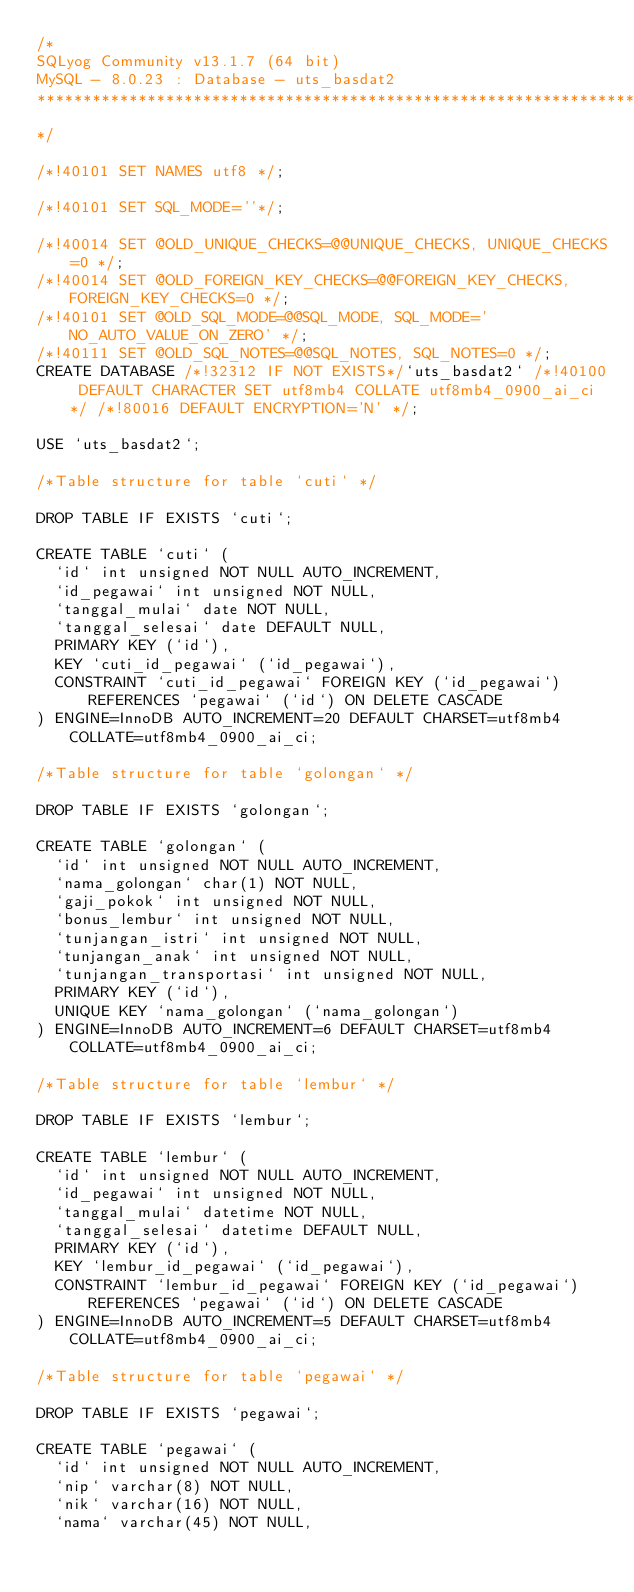Convert code to text. <code><loc_0><loc_0><loc_500><loc_500><_SQL_>/*
SQLyog Community v13.1.7 (64 bit)
MySQL - 8.0.23 : Database - uts_basdat2
*********************************************************************
*/

/*!40101 SET NAMES utf8 */;

/*!40101 SET SQL_MODE=''*/;

/*!40014 SET @OLD_UNIQUE_CHECKS=@@UNIQUE_CHECKS, UNIQUE_CHECKS=0 */;
/*!40014 SET @OLD_FOREIGN_KEY_CHECKS=@@FOREIGN_KEY_CHECKS, FOREIGN_KEY_CHECKS=0 */;
/*!40101 SET @OLD_SQL_MODE=@@SQL_MODE, SQL_MODE='NO_AUTO_VALUE_ON_ZERO' */;
/*!40111 SET @OLD_SQL_NOTES=@@SQL_NOTES, SQL_NOTES=0 */;
CREATE DATABASE /*!32312 IF NOT EXISTS*/`uts_basdat2` /*!40100 DEFAULT CHARACTER SET utf8mb4 COLLATE utf8mb4_0900_ai_ci */ /*!80016 DEFAULT ENCRYPTION='N' */;

USE `uts_basdat2`;

/*Table structure for table `cuti` */

DROP TABLE IF EXISTS `cuti`;

CREATE TABLE `cuti` (
  `id` int unsigned NOT NULL AUTO_INCREMENT,
  `id_pegawai` int unsigned NOT NULL,
  `tanggal_mulai` date NOT NULL,
  `tanggal_selesai` date DEFAULT NULL,
  PRIMARY KEY (`id`),
  KEY `cuti_id_pegawai` (`id_pegawai`),
  CONSTRAINT `cuti_id_pegawai` FOREIGN KEY (`id_pegawai`) REFERENCES `pegawai` (`id`) ON DELETE CASCADE
) ENGINE=InnoDB AUTO_INCREMENT=20 DEFAULT CHARSET=utf8mb4 COLLATE=utf8mb4_0900_ai_ci;

/*Table structure for table `golongan` */

DROP TABLE IF EXISTS `golongan`;

CREATE TABLE `golongan` (
  `id` int unsigned NOT NULL AUTO_INCREMENT,
  `nama_golongan` char(1) NOT NULL,
  `gaji_pokok` int unsigned NOT NULL,
  `bonus_lembur` int unsigned NOT NULL,
  `tunjangan_istri` int unsigned NOT NULL,
  `tunjangan_anak` int unsigned NOT NULL,
  `tunjangan_transportasi` int unsigned NOT NULL,
  PRIMARY KEY (`id`),
  UNIQUE KEY `nama_golongan` (`nama_golongan`)
) ENGINE=InnoDB AUTO_INCREMENT=6 DEFAULT CHARSET=utf8mb4 COLLATE=utf8mb4_0900_ai_ci;

/*Table structure for table `lembur` */

DROP TABLE IF EXISTS `lembur`;

CREATE TABLE `lembur` (
  `id` int unsigned NOT NULL AUTO_INCREMENT,
  `id_pegawai` int unsigned NOT NULL,
  `tanggal_mulai` datetime NOT NULL,
  `tanggal_selesai` datetime DEFAULT NULL,
  PRIMARY KEY (`id`),
  KEY `lembur_id_pegawai` (`id_pegawai`),
  CONSTRAINT `lembur_id_pegawai` FOREIGN KEY (`id_pegawai`) REFERENCES `pegawai` (`id`) ON DELETE CASCADE
) ENGINE=InnoDB AUTO_INCREMENT=5 DEFAULT CHARSET=utf8mb4 COLLATE=utf8mb4_0900_ai_ci;

/*Table structure for table `pegawai` */

DROP TABLE IF EXISTS `pegawai`;

CREATE TABLE `pegawai` (
  `id` int unsigned NOT NULL AUTO_INCREMENT,
  `nip` varchar(8) NOT NULL,
  `nik` varchar(16) NOT NULL,
  `nama` varchar(45) NOT NULL,</code> 